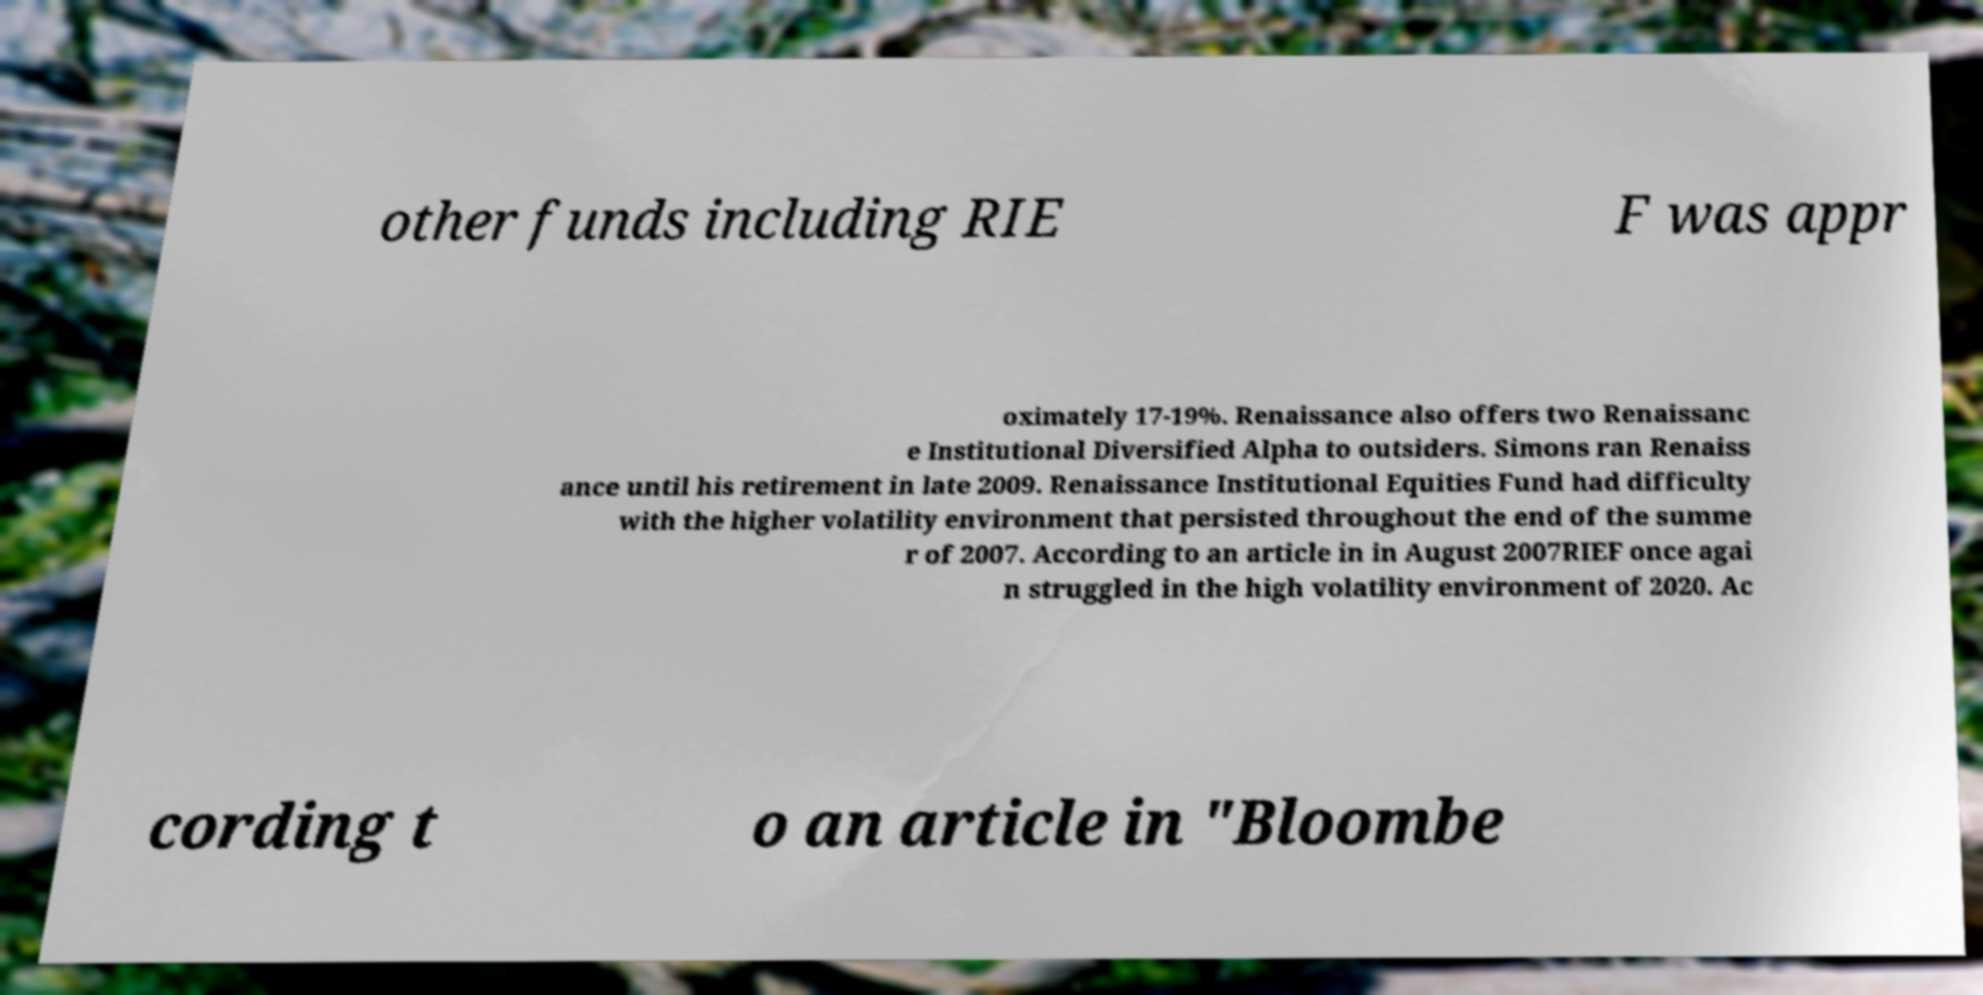Please read and relay the text visible in this image. What does it say? other funds including RIE F was appr oximately 17-19%. Renaissance also offers two Renaissanc e Institutional Diversified Alpha to outsiders. Simons ran Renaiss ance until his retirement in late 2009. Renaissance Institutional Equities Fund had difficulty with the higher volatility environment that persisted throughout the end of the summe r of 2007. According to an article in in August 2007RIEF once agai n struggled in the high volatility environment of 2020. Ac cording t o an article in "Bloombe 